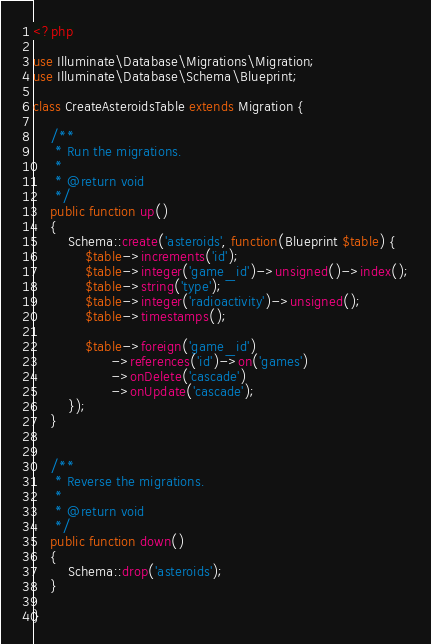Convert code to text. <code><loc_0><loc_0><loc_500><loc_500><_PHP_><?php

use Illuminate\Database\Migrations\Migration;
use Illuminate\Database\Schema\Blueprint;

class CreateAsteroidsTable extends Migration {

	/**
	 * Run the migrations.
	 *
	 * @return void
	 */
	public function up()
	{
		Schema::create('asteroids', function(Blueprint $table) {
			$table->increments('id');
			$table->integer('game_id')->unsigned()->index();
			$table->string('type');
			$table->integer('radioactivity')->unsigned();
			$table->timestamps();

			$table->foreign('game_id')
			      ->references('id')->on('games')
			      ->onDelete('cascade')
			      ->onUpdate('cascade');
		});
	}


	/**
	 * Reverse the migrations.
	 *
	 * @return void
	 */
	public function down()
	{
		Schema::drop('asteroids');
	}

}
</code> 